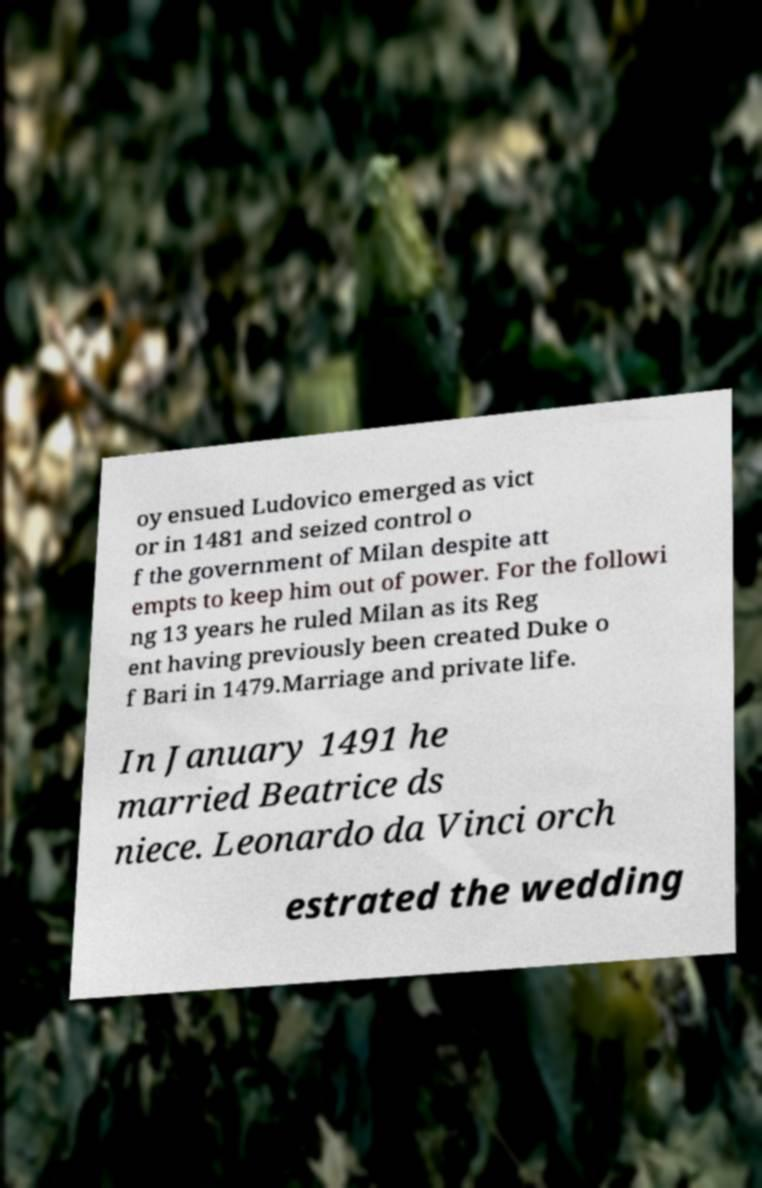There's text embedded in this image that I need extracted. Can you transcribe it verbatim? oy ensued Ludovico emerged as vict or in 1481 and seized control o f the government of Milan despite att empts to keep him out of power. For the followi ng 13 years he ruled Milan as its Reg ent having previously been created Duke o f Bari in 1479.Marriage and private life. In January 1491 he married Beatrice ds niece. Leonardo da Vinci orch estrated the wedding 